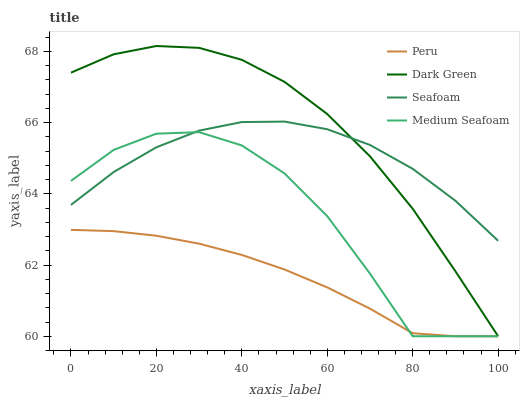Does Peru have the minimum area under the curve?
Answer yes or no. Yes. Does Dark Green have the maximum area under the curve?
Answer yes or no. Yes. Does Seafoam have the minimum area under the curve?
Answer yes or no. No. Does Seafoam have the maximum area under the curve?
Answer yes or no. No. Is Peru the smoothest?
Answer yes or no. Yes. Is Medium Seafoam the roughest?
Answer yes or no. Yes. Is Seafoam the smoothest?
Answer yes or no. No. Is Seafoam the roughest?
Answer yes or no. No. Does Medium Seafoam have the lowest value?
Answer yes or no. Yes. Does Seafoam have the lowest value?
Answer yes or no. No. Does Dark Green have the highest value?
Answer yes or no. Yes. Does Seafoam have the highest value?
Answer yes or no. No. Is Peru less than Seafoam?
Answer yes or no. Yes. Is Seafoam greater than Peru?
Answer yes or no. Yes. Does Seafoam intersect Dark Green?
Answer yes or no. Yes. Is Seafoam less than Dark Green?
Answer yes or no. No. Is Seafoam greater than Dark Green?
Answer yes or no. No. Does Peru intersect Seafoam?
Answer yes or no. No. 